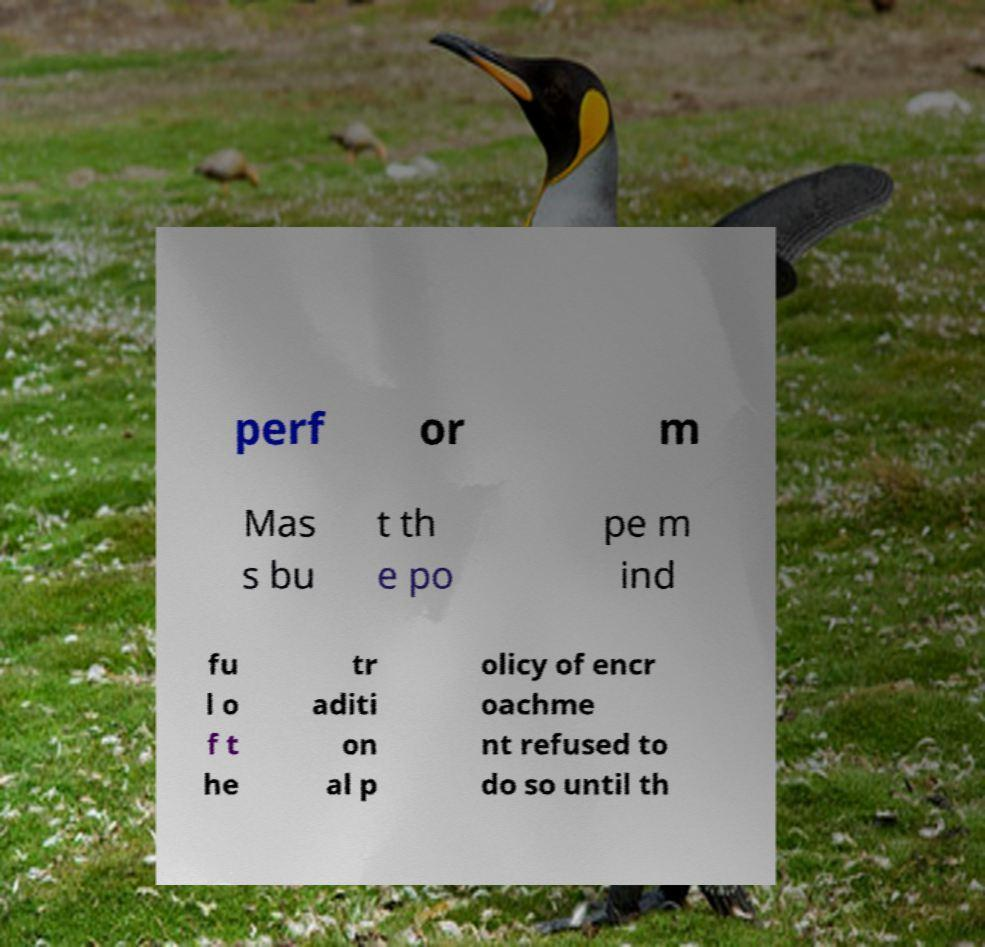What messages or text are displayed in this image? I need them in a readable, typed format. perf or m Mas s bu t th e po pe m ind fu l o f t he tr aditi on al p olicy of encr oachme nt refused to do so until th 